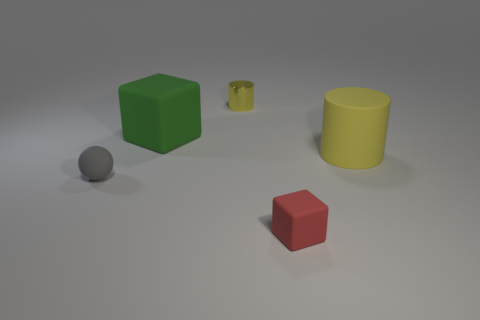Add 2 brown balls. How many objects exist? 7 Subtract all balls. How many objects are left? 4 Subtract 2 cubes. How many cubes are left? 0 Subtract all purple cylinders. Subtract all cyan cubes. How many cylinders are left? 2 Subtract all brown blocks. How many green spheres are left? 0 Subtract all red things. Subtract all red blocks. How many objects are left? 3 Add 4 large cubes. How many large cubes are left? 5 Add 3 large yellow matte cylinders. How many large yellow matte cylinders exist? 4 Subtract 0 purple cylinders. How many objects are left? 5 